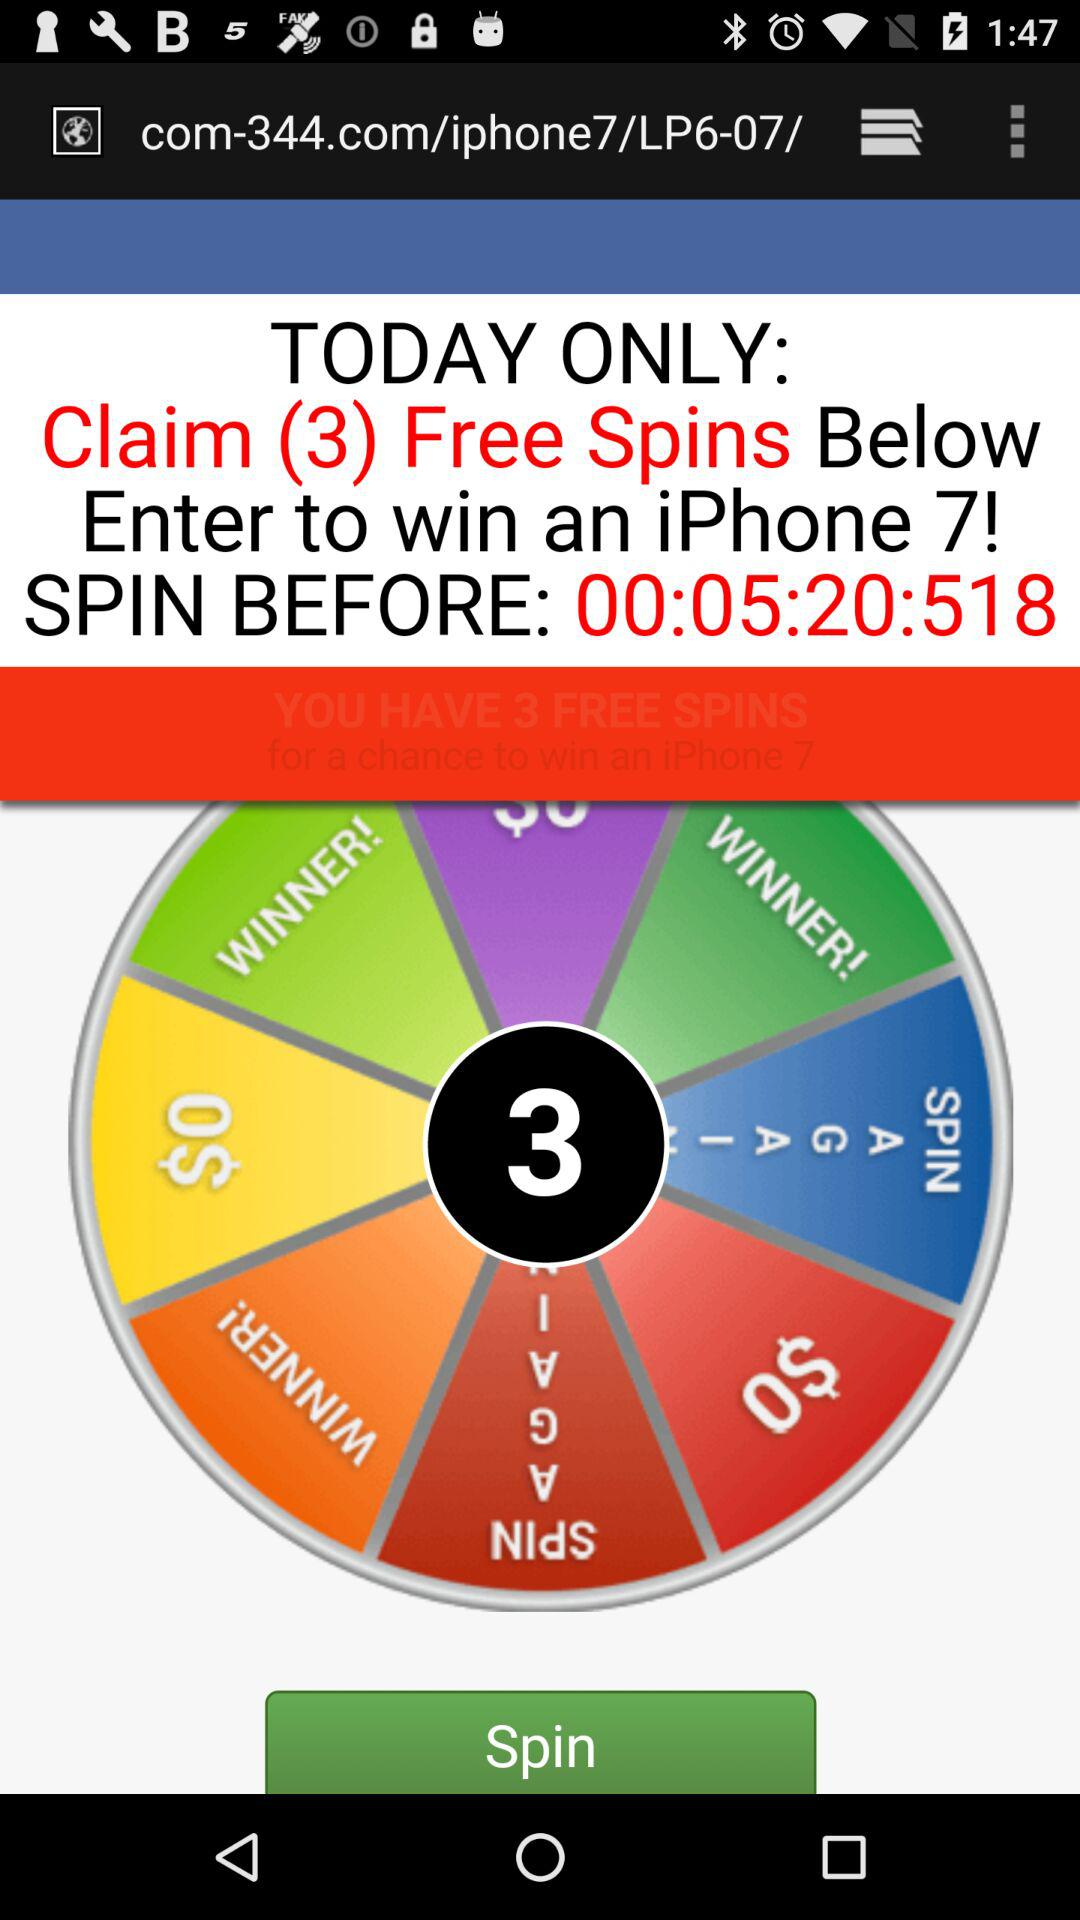What should I be cautious about when participating in contests like this? When participating in contests like the one shown, be cautious about providing personal information, understand the site's privacy policy, and confirm if there are any costs associated with participation. Also, check if the contest is legitimate and not a phishing attempt. 